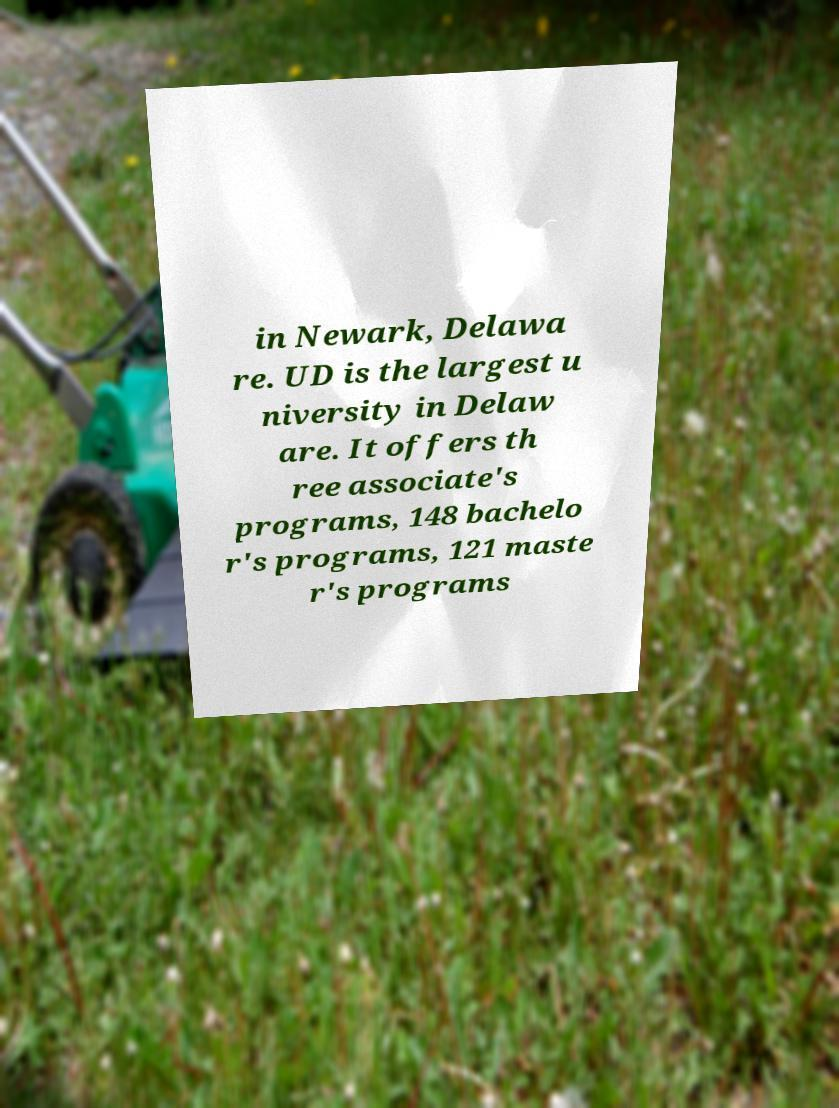Could you extract and type out the text from this image? in Newark, Delawa re. UD is the largest u niversity in Delaw are. It offers th ree associate's programs, 148 bachelo r's programs, 121 maste r's programs 